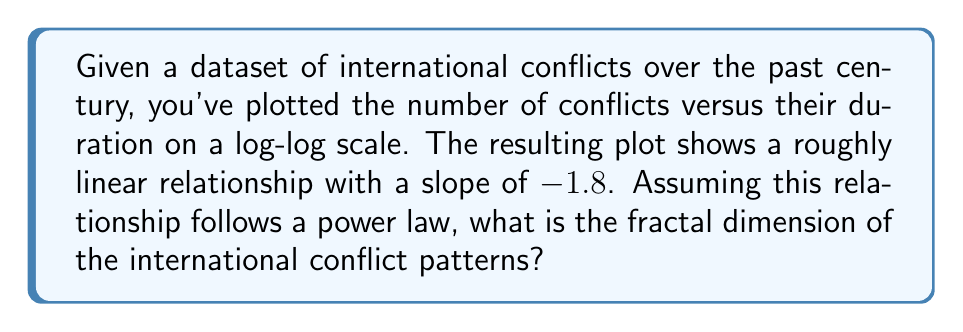Teach me how to tackle this problem. To determine the fractal dimension of international conflict patterns, we'll follow these steps:

1) In a log-log plot of number of conflicts (N) versus duration (r), a linear relationship indicates a power law of the form:

   $$N(r) \propto r^{-D}$$

   where D is the fractal dimension we're seeking.

2) The slope of the log-log plot is related to D. If we call the slope m, then:

   $$m = -D$$

3) In this case, we're given that the slope m = -1.8

4) Therefore, the fractal dimension D is the negative of this slope:

   $$D = -m = -(-1.8) = 1.8$$

5) This fractal dimension (1.8) suggests that international conflict patterns exhibit fractal-like behavior, with a dimension between a line (D=1) and a plane (D=2). This could indicate a complex, self-similar structure in conflict patterns across different scales of duration.

6) In the context of international relations and gender in security policies, this fractal dimension might reflect how conflicts at different scales (from brief skirmishes to long-term wars) show similar patterns, possibly influenced by persistent gender-related factors in conflict initiation, escalation, and resolution.
Answer: 1.8 